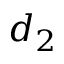<formula> <loc_0><loc_0><loc_500><loc_500>d _ { 2 }</formula> 